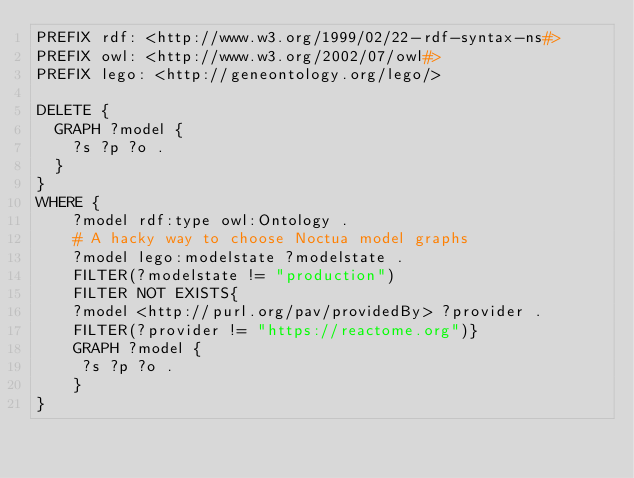<code> <loc_0><loc_0><loc_500><loc_500><_Ruby_>PREFIX rdf: <http://www.w3.org/1999/02/22-rdf-syntax-ns#>
PREFIX owl: <http://www.w3.org/2002/07/owl#>
PREFIX lego: <http://geneontology.org/lego/>

DELETE {
  GRAPH ?model {
    ?s ?p ?o .
  }
}
WHERE {
    ?model rdf:type owl:Ontology .
    # A hacky way to choose Noctua model graphs
    ?model lego:modelstate ?modelstate .
    FILTER(?modelstate != "production")
    FILTER NOT EXISTS{
    ?model <http://purl.org/pav/providedBy> ?provider .
    FILTER(?provider != "https://reactome.org")}
    GRAPH ?model {
     ?s ?p ?o .
    }
}
</code> 